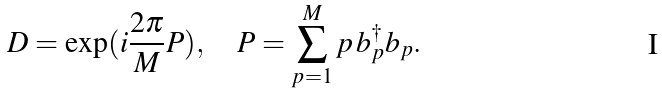<formula> <loc_0><loc_0><loc_500><loc_500>D = \exp ( i \frac { 2 \pi } { M } P ) , \quad P = \sum _ { p = 1 } ^ { M } p \, b ^ { \dag } _ { p } b _ { p } .</formula> 